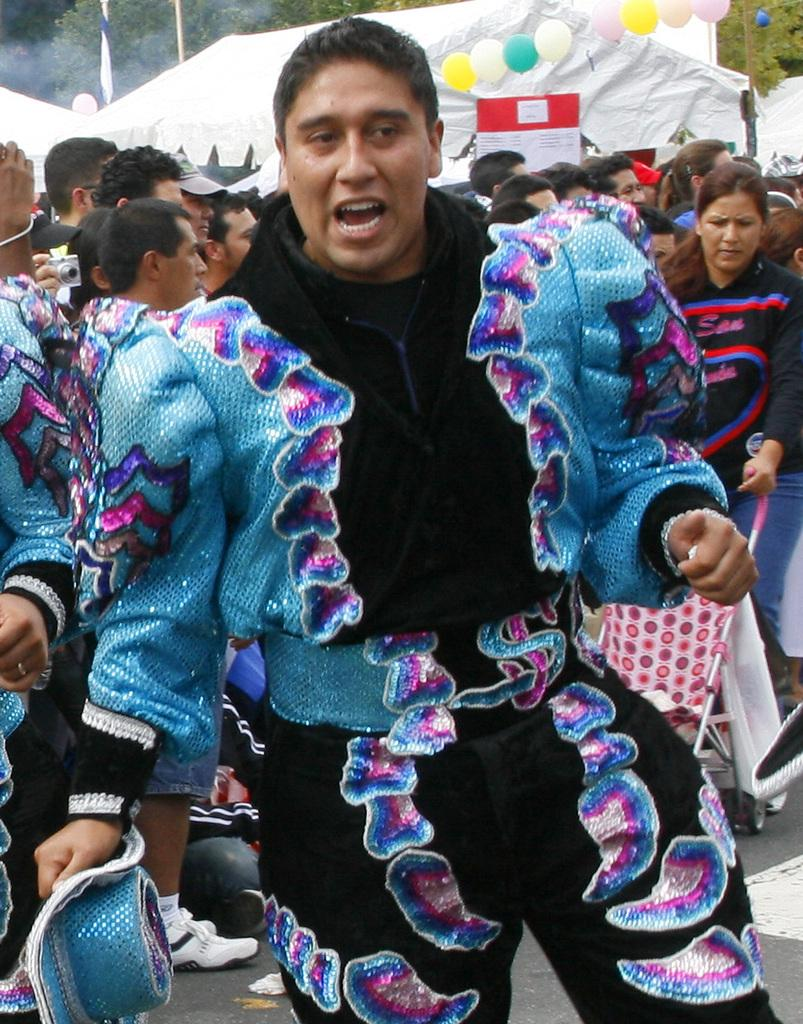What is the man in the image wearing? The man in the image is wearing a fancy dress. Who is standing behind the man in the image? There is a group of people standing behind the man in the image. What can be seen in the background of the image? In the background of the image, there is a ten, a board, balloons, and trees. What type of drink is the man holding in the image? There is no drink visible in the image; the man is not holding anything. 